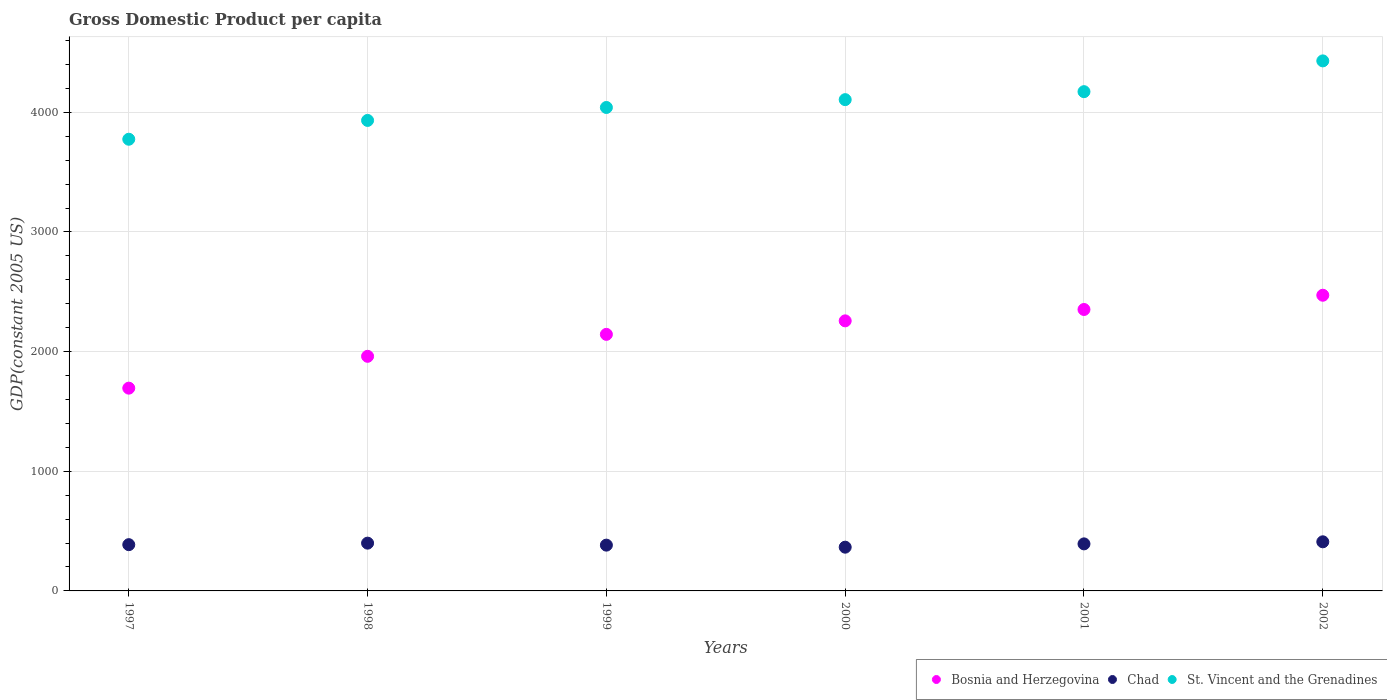How many different coloured dotlines are there?
Ensure brevity in your answer.  3. What is the GDP per capita in Bosnia and Herzegovina in 2002?
Give a very brief answer. 2471.17. Across all years, what is the maximum GDP per capita in Bosnia and Herzegovina?
Your answer should be very brief. 2471.17. Across all years, what is the minimum GDP per capita in St. Vincent and the Grenadines?
Offer a terse response. 3774.94. In which year was the GDP per capita in Bosnia and Herzegovina minimum?
Keep it short and to the point. 1997. What is the total GDP per capita in Chad in the graph?
Keep it short and to the point. 2337.76. What is the difference between the GDP per capita in St. Vincent and the Grenadines in 1999 and that in 2001?
Offer a terse response. -132.1. What is the difference between the GDP per capita in St. Vincent and the Grenadines in 1997 and the GDP per capita in Bosnia and Herzegovina in 2000?
Your answer should be compact. 1517.89. What is the average GDP per capita in Chad per year?
Offer a very short reply. 389.63. In the year 1998, what is the difference between the GDP per capita in St. Vincent and the Grenadines and GDP per capita in Chad?
Make the answer very short. 3532.86. In how many years, is the GDP per capita in Chad greater than 2800 US$?
Keep it short and to the point. 0. What is the ratio of the GDP per capita in St. Vincent and the Grenadines in 1997 to that in 1998?
Offer a terse response. 0.96. What is the difference between the highest and the second highest GDP per capita in St. Vincent and the Grenadines?
Your answer should be very brief. 257.24. What is the difference between the highest and the lowest GDP per capita in St. Vincent and the Grenadines?
Your answer should be compact. 654.8. In how many years, is the GDP per capita in St. Vincent and the Grenadines greater than the average GDP per capita in St. Vincent and the Grenadines taken over all years?
Make the answer very short. 3. Does the GDP per capita in St. Vincent and the Grenadines monotonically increase over the years?
Your answer should be very brief. Yes. How many years are there in the graph?
Give a very brief answer. 6. Are the values on the major ticks of Y-axis written in scientific E-notation?
Keep it short and to the point. No. Does the graph contain any zero values?
Ensure brevity in your answer.  No. Where does the legend appear in the graph?
Offer a terse response. Bottom right. How many legend labels are there?
Give a very brief answer. 3. How are the legend labels stacked?
Your answer should be compact. Horizontal. What is the title of the graph?
Make the answer very short. Gross Domestic Product per capita. What is the label or title of the Y-axis?
Your answer should be compact. GDP(constant 2005 US). What is the GDP(constant 2005 US) in Bosnia and Herzegovina in 1997?
Provide a succinct answer. 1694.62. What is the GDP(constant 2005 US) in Chad in 1997?
Provide a short and direct response. 386.6. What is the GDP(constant 2005 US) in St. Vincent and the Grenadines in 1997?
Your response must be concise. 3774.94. What is the GDP(constant 2005 US) in Bosnia and Herzegovina in 1998?
Offer a terse response. 1960.77. What is the GDP(constant 2005 US) of Chad in 1998?
Offer a very short reply. 399.3. What is the GDP(constant 2005 US) of St. Vincent and the Grenadines in 1998?
Offer a very short reply. 3932.16. What is the GDP(constant 2005 US) in Bosnia and Herzegovina in 1999?
Offer a very short reply. 2144.18. What is the GDP(constant 2005 US) of Chad in 1999?
Give a very brief answer. 382.64. What is the GDP(constant 2005 US) in St. Vincent and the Grenadines in 1999?
Provide a short and direct response. 4040.4. What is the GDP(constant 2005 US) in Bosnia and Herzegovina in 2000?
Give a very brief answer. 2257.05. What is the GDP(constant 2005 US) in Chad in 2000?
Your answer should be very brief. 365.61. What is the GDP(constant 2005 US) in St. Vincent and the Grenadines in 2000?
Ensure brevity in your answer.  4105.87. What is the GDP(constant 2005 US) in Bosnia and Herzegovina in 2001?
Your answer should be compact. 2352.1. What is the GDP(constant 2005 US) in Chad in 2001?
Your answer should be very brief. 393.14. What is the GDP(constant 2005 US) of St. Vincent and the Grenadines in 2001?
Your response must be concise. 4172.5. What is the GDP(constant 2005 US) of Bosnia and Herzegovina in 2002?
Keep it short and to the point. 2471.17. What is the GDP(constant 2005 US) of Chad in 2002?
Your response must be concise. 410.48. What is the GDP(constant 2005 US) of St. Vincent and the Grenadines in 2002?
Your response must be concise. 4429.74. Across all years, what is the maximum GDP(constant 2005 US) of Bosnia and Herzegovina?
Your answer should be very brief. 2471.17. Across all years, what is the maximum GDP(constant 2005 US) in Chad?
Your response must be concise. 410.48. Across all years, what is the maximum GDP(constant 2005 US) of St. Vincent and the Grenadines?
Your answer should be compact. 4429.74. Across all years, what is the minimum GDP(constant 2005 US) of Bosnia and Herzegovina?
Offer a very short reply. 1694.62. Across all years, what is the minimum GDP(constant 2005 US) of Chad?
Your answer should be compact. 365.61. Across all years, what is the minimum GDP(constant 2005 US) of St. Vincent and the Grenadines?
Keep it short and to the point. 3774.94. What is the total GDP(constant 2005 US) of Bosnia and Herzegovina in the graph?
Provide a succinct answer. 1.29e+04. What is the total GDP(constant 2005 US) of Chad in the graph?
Offer a very short reply. 2337.76. What is the total GDP(constant 2005 US) of St. Vincent and the Grenadines in the graph?
Give a very brief answer. 2.45e+04. What is the difference between the GDP(constant 2005 US) in Bosnia and Herzegovina in 1997 and that in 1998?
Make the answer very short. -266.15. What is the difference between the GDP(constant 2005 US) of Chad in 1997 and that in 1998?
Your answer should be very brief. -12.7. What is the difference between the GDP(constant 2005 US) in St. Vincent and the Grenadines in 1997 and that in 1998?
Make the answer very short. -157.22. What is the difference between the GDP(constant 2005 US) in Bosnia and Herzegovina in 1997 and that in 1999?
Keep it short and to the point. -449.57. What is the difference between the GDP(constant 2005 US) of Chad in 1997 and that in 1999?
Offer a very short reply. 3.96. What is the difference between the GDP(constant 2005 US) of St. Vincent and the Grenadines in 1997 and that in 1999?
Your answer should be very brief. -265.46. What is the difference between the GDP(constant 2005 US) of Bosnia and Herzegovina in 1997 and that in 2000?
Your answer should be very brief. -562.43. What is the difference between the GDP(constant 2005 US) of Chad in 1997 and that in 2000?
Give a very brief answer. 20.99. What is the difference between the GDP(constant 2005 US) in St. Vincent and the Grenadines in 1997 and that in 2000?
Ensure brevity in your answer.  -330.93. What is the difference between the GDP(constant 2005 US) of Bosnia and Herzegovina in 1997 and that in 2001?
Your answer should be compact. -657.48. What is the difference between the GDP(constant 2005 US) of Chad in 1997 and that in 2001?
Provide a short and direct response. -6.54. What is the difference between the GDP(constant 2005 US) in St. Vincent and the Grenadines in 1997 and that in 2001?
Make the answer very short. -397.56. What is the difference between the GDP(constant 2005 US) of Bosnia and Herzegovina in 1997 and that in 2002?
Keep it short and to the point. -776.55. What is the difference between the GDP(constant 2005 US) of Chad in 1997 and that in 2002?
Your answer should be compact. -23.89. What is the difference between the GDP(constant 2005 US) in St. Vincent and the Grenadines in 1997 and that in 2002?
Keep it short and to the point. -654.8. What is the difference between the GDP(constant 2005 US) in Bosnia and Herzegovina in 1998 and that in 1999?
Keep it short and to the point. -183.41. What is the difference between the GDP(constant 2005 US) in Chad in 1998 and that in 1999?
Provide a short and direct response. 16.66. What is the difference between the GDP(constant 2005 US) in St. Vincent and the Grenadines in 1998 and that in 1999?
Provide a succinct answer. -108.24. What is the difference between the GDP(constant 2005 US) in Bosnia and Herzegovina in 1998 and that in 2000?
Provide a succinct answer. -296.28. What is the difference between the GDP(constant 2005 US) of Chad in 1998 and that in 2000?
Your answer should be very brief. 33.69. What is the difference between the GDP(constant 2005 US) of St. Vincent and the Grenadines in 1998 and that in 2000?
Provide a short and direct response. -173.72. What is the difference between the GDP(constant 2005 US) in Bosnia and Herzegovina in 1998 and that in 2001?
Give a very brief answer. -391.33. What is the difference between the GDP(constant 2005 US) of Chad in 1998 and that in 2001?
Your answer should be very brief. 6.16. What is the difference between the GDP(constant 2005 US) of St. Vincent and the Grenadines in 1998 and that in 2001?
Give a very brief answer. -240.35. What is the difference between the GDP(constant 2005 US) of Bosnia and Herzegovina in 1998 and that in 2002?
Offer a terse response. -510.4. What is the difference between the GDP(constant 2005 US) in Chad in 1998 and that in 2002?
Your answer should be compact. -11.19. What is the difference between the GDP(constant 2005 US) of St. Vincent and the Grenadines in 1998 and that in 2002?
Make the answer very short. -497.58. What is the difference between the GDP(constant 2005 US) of Bosnia and Herzegovina in 1999 and that in 2000?
Your response must be concise. -112.87. What is the difference between the GDP(constant 2005 US) in Chad in 1999 and that in 2000?
Give a very brief answer. 17.03. What is the difference between the GDP(constant 2005 US) in St. Vincent and the Grenadines in 1999 and that in 2000?
Ensure brevity in your answer.  -65.47. What is the difference between the GDP(constant 2005 US) of Bosnia and Herzegovina in 1999 and that in 2001?
Offer a terse response. -207.92. What is the difference between the GDP(constant 2005 US) of Chad in 1999 and that in 2001?
Your response must be concise. -10.5. What is the difference between the GDP(constant 2005 US) of St. Vincent and the Grenadines in 1999 and that in 2001?
Keep it short and to the point. -132.1. What is the difference between the GDP(constant 2005 US) in Bosnia and Herzegovina in 1999 and that in 2002?
Provide a short and direct response. -326.99. What is the difference between the GDP(constant 2005 US) of Chad in 1999 and that in 2002?
Ensure brevity in your answer.  -27.84. What is the difference between the GDP(constant 2005 US) of St. Vincent and the Grenadines in 1999 and that in 2002?
Ensure brevity in your answer.  -389.34. What is the difference between the GDP(constant 2005 US) in Bosnia and Herzegovina in 2000 and that in 2001?
Offer a terse response. -95.05. What is the difference between the GDP(constant 2005 US) of Chad in 2000 and that in 2001?
Provide a short and direct response. -27.53. What is the difference between the GDP(constant 2005 US) of St. Vincent and the Grenadines in 2000 and that in 2001?
Your response must be concise. -66.63. What is the difference between the GDP(constant 2005 US) in Bosnia and Herzegovina in 2000 and that in 2002?
Give a very brief answer. -214.12. What is the difference between the GDP(constant 2005 US) in Chad in 2000 and that in 2002?
Your answer should be compact. -44.88. What is the difference between the GDP(constant 2005 US) in St. Vincent and the Grenadines in 2000 and that in 2002?
Offer a terse response. -323.87. What is the difference between the GDP(constant 2005 US) in Bosnia and Herzegovina in 2001 and that in 2002?
Your response must be concise. -119.07. What is the difference between the GDP(constant 2005 US) in Chad in 2001 and that in 2002?
Keep it short and to the point. -17.34. What is the difference between the GDP(constant 2005 US) in St. Vincent and the Grenadines in 2001 and that in 2002?
Ensure brevity in your answer.  -257.24. What is the difference between the GDP(constant 2005 US) in Bosnia and Herzegovina in 1997 and the GDP(constant 2005 US) in Chad in 1998?
Your answer should be compact. 1295.32. What is the difference between the GDP(constant 2005 US) in Bosnia and Herzegovina in 1997 and the GDP(constant 2005 US) in St. Vincent and the Grenadines in 1998?
Your answer should be very brief. -2237.54. What is the difference between the GDP(constant 2005 US) of Chad in 1997 and the GDP(constant 2005 US) of St. Vincent and the Grenadines in 1998?
Provide a succinct answer. -3545.56. What is the difference between the GDP(constant 2005 US) in Bosnia and Herzegovina in 1997 and the GDP(constant 2005 US) in Chad in 1999?
Your answer should be very brief. 1311.98. What is the difference between the GDP(constant 2005 US) of Bosnia and Herzegovina in 1997 and the GDP(constant 2005 US) of St. Vincent and the Grenadines in 1999?
Provide a short and direct response. -2345.78. What is the difference between the GDP(constant 2005 US) of Chad in 1997 and the GDP(constant 2005 US) of St. Vincent and the Grenadines in 1999?
Your response must be concise. -3653.8. What is the difference between the GDP(constant 2005 US) of Bosnia and Herzegovina in 1997 and the GDP(constant 2005 US) of Chad in 2000?
Make the answer very short. 1329.01. What is the difference between the GDP(constant 2005 US) in Bosnia and Herzegovina in 1997 and the GDP(constant 2005 US) in St. Vincent and the Grenadines in 2000?
Offer a terse response. -2411.26. What is the difference between the GDP(constant 2005 US) in Chad in 1997 and the GDP(constant 2005 US) in St. Vincent and the Grenadines in 2000?
Your answer should be very brief. -3719.28. What is the difference between the GDP(constant 2005 US) of Bosnia and Herzegovina in 1997 and the GDP(constant 2005 US) of Chad in 2001?
Provide a short and direct response. 1301.48. What is the difference between the GDP(constant 2005 US) in Bosnia and Herzegovina in 1997 and the GDP(constant 2005 US) in St. Vincent and the Grenadines in 2001?
Offer a very short reply. -2477.88. What is the difference between the GDP(constant 2005 US) of Chad in 1997 and the GDP(constant 2005 US) of St. Vincent and the Grenadines in 2001?
Your response must be concise. -3785.91. What is the difference between the GDP(constant 2005 US) of Bosnia and Herzegovina in 1997 and the GDP(constant 2005 US) of Chad in 2002?
Offer a very short reply. 1284.14. What is the difference between the GDP(constant 2005 US) of Bosnia and Herzegovina in 1997 and the GDP(constant 2005 US) of St. Vincent and the Grenadines in 2002?
Your answer should be very brief. -2735.12. What is the difference between the GDP(constant 2005 US) in Chad in 1997 and the GDP(constant 2005 US) in St. Vincent and the Grenadines in 2002?
Your answer should be very brief. -4043.14. What is the difference between the GDP(constant 2005 US) of Bosnia and Herzegovina in 1998 and the GDP(constant 2005 US) of Chad in 1999?
Your response must be concise. 1578.13. What is the difference between the GDP(constant 2005 US) in Bosnia and Herzegovina in 1998 and the GDP(constant 2005 US) in St. Vincent and the Grenadines in 1999?
Make the answer very short. -2079.63. What is the difference between the GDP(constant 2005 US) of Chad in 1998 and the GDP(constant 2005 US) of St. Vincent and the Grenadines in 1999?
Offer a very short reply. -3641.1. What is the difference between the GDP(constant 2005 US) of Bosnia and Herzegovina in 1998 and the GDP(constant 2005 US) of Chad in 2000?
Your answer should be very brief. 1595.16. What is the difference between the GDP(constant 2005 US) of Bosnia and Herzegovina in 1998 and the GDP(constant 2005 US) of St. Vincent and the Grenadines in 2000?
Your answer should be compact. -2145.1. What is the difference between the GDP(constant 2005 US) of Chad in 1998 and the GDP(constant 2005 US) of St. Vincent and the Grenadines in 2000?
Your response must be concise. -3706.58. What is the difference between the GDP(constant 2005 US) of Bosnia and Herzegovina in 1998 and the GDP(constant 2005 US) of Chad in 2001?
Give a very brief answer. 1567.63. What is the difference between the GDP(constant 2005 US) in Bosnia and Herzegovina in 1998 and the GDP(constant 2005 US) in St. Vincent and the Grenadines in 2001?
Give a very brief answer. -2211.73. What is the difference between the GDP(constant 2005 US) in Chad in 1998 and the GDP(constant 2005 US) in St. Vincent and the Grenadines in 2001?
Ensure brevity in your answer.  -3773.21. What is the difference between the GDP(constant 2005 US) of Bosnia and Herzegovina in 1998 and the GDP(constant 2005 US) of Chad in 2002?
Ensure brevity in your answer.  1550.29. What is the difference between the GDP(constant 2005 US) in Bosnia and Herzegovina in 1998 and the GDP(constant 2005 US) in St. Vincent and the Grenadines in 2002?
Your answer should be very brief. -2468.97. What is the difference between the GDP(constant 2005 US) of Chad in 1998 and the GDP(constant 2005 US) of St. Vincent and the Grenadines in 2002?
Offer a very short reply. -4030.44. What is the difference between the GDP(constant 2005 US) in Bosnia and Herzegovina in 1999 and the GDP(constant 2005 US) in Chad in 2000?
Your answer should be very brief. 1778.58. What is the difference between the GDP(constant 2005 US) of Bosnia and Herzegovina in 1999 and the GDP(constant 2005 US) of St. Vincent and the Grenadines in 2000?
Provide a succinct answer. -1961.69. What is the difference between the GDP(constant 2005 US) in Chad in 1999 and the GDP(constant 2005 US) in St. Vincent and the Grenadines in 2000?
Offer a very short reply. -3723.24. What is the difference between the GDP(constant 2005 US) of Bosnia and Herzegovina in 1999 and the GDP(constant 2005 US) of Chad in 2001?
Provide a short and direct response. 1751.05. What is the difference between the GDP(constant 2005 US) in Bosnia and Herzegovina in 1999 and the GDP(constant 2005 US) in St. Vincent and the Grenadines in 2001?
Offer a terse response. -2028.32. What is the difference between the GDP(constant 2005 US) of Chad in 1999 and the GDP(constant 2005 US) of St. Vincent and the Grenadines in 2001?
Provide a succinct answer. -3789.86. What is the difference between the GDP(constant 2005 US) in Bosnia and Herzegovina in 1999 and the GDP(constant 2005 US) in Chad in 2002?
Keep it short and to the point. 1733.7. What is the difference between the GDP(constant 2005 US) in Bosnia and Herzegovina in 1999 and the GDP(constant 2005 US) in St. Vincent and the Grenadines in 2002?
Your response must be concise. -2285.56. What is the difference between the GDP(constant 2005 US) of Chad in 1999 and the GDP(constant 2005 US) of St. Vincent and the Grenadines in 2002?
Make the answer very short. -4047.1. What is the difference between the GDP(constant 2005 US) of Bosnia and Herzegovina in 2000 and the GDP(constant 2005 US) of Chad in 2001?
Offer a very short reply. 1863.91. What is the difference between the GDP(constant 2005 US) in Bosnia and Herzegovina in 2000 and the GDP(constant 2005 US) in St. Vincent and the Grenadines in 2001?
Your response must be concise. -1915.45. What is the difference between the GDP(constant 2005 US) of Chad in 2000 and the GDP(constant 2005 US) of St. Vincent and the Grenadines in 2001?
Give a very brief answer. -3806.9. What is the difference between the GDP(constant 2005 US) in Bosnia and Herzegovina in 2000 and the GDP(constant 2005 US) in Chad in 2002?
Ensure brevity in your answer.  1846.57. What is the difference between the GDP(constant 2005 US) in Bosnia and Herzegovina in 2000 and the GDP(constant 2005 US) in St. Vincent and the Grenadines in 2002?
Your response must be concise. -2172.69. What is the difference between the GDP(constant 2005 US) of Chad in 2000 and the GDP(constant 2005 US) of St. Vincent and the Grenadines in 2002?
Offer a very short reply. -4064.13. What is the difference between the GDP(constant 2005 US) in Bosnia and Herzegovina in 2001 and the GDP(constant 2005 US) in Chad in 2002?
Make the answer very short. 1941.62. What is the difference between the GDP(constant 2005 US) of Bosnia and Herzegovina in 2001 and the GDP(constant 2005 US) of St. Vincent and the Grenadines in 2002?
Provide a short and direct response. -2077.64. What is the difference between the GDP(constant 2005 US) in Chad in 2001 and the GDP(constant 2005 US) in St. Vincent and the Grenadines in 2002?
Offer a very short reply. -4036.6. What is the average GDP(constant 2005 US) in Bosnia and Herzegovina per year?
Make the answer very short. 2146.65. What is the average GDP(constant 2005 US) of Chad per year?
Offer a very short reply. 389.63. What is the average GDP(constant 2005 US) in St. Vincent and the Grenadines per year?
Offer a terse response. 4075.93. In the year 1997, what is the difference between the GDP(constant 2005 US) of Bosnia and Herzegovina and GDP(constant 2005 US) of Chad?
Ensure brevity in your answer.  1308.02. In the year 1997, what is the difference between the GDP(constant 2005 US) of Bosnia and Herzegovina and GDP(constant 2005 US) of St. Vincent and the Grenadines?
Your response must be concise. -2080.32. In the year 1997, what is the difference between the GDP(constant 2005 US) in Chad and GDP(constant 2005 US) in St. Vincent and the Grenadines?
Your answer should be compact. -3388.34. In the year 1998, what is the difference between the GDP(constant 2005 US) of Bosnia and Herzegovina and GDP(constant 2005 US) of Chad?
Give a very brief answer. 1561.47. In the year 1998, what is the difference between the GDP(constant 2005 US) of Bosnia and Herzegovina and GDP(constant 2005 US) of St. Vincent and the Grenadines?
Your response must be concise. -1971.38. In the year 1998, what is the difference between the GDP(constant 2005 US) of Chad and GDP(constant 2005 US) of St. Vincent and the Grenadines?
Ensure brevity in your answer.  -3532.86. In the year 1999, what is the difference between the GDP(constant 2005 US) of Bosnia and Herzegovina and GDP(constant 2005 US) of Chad?
Offer a very short reply. 1761.55. In the year 1999, what is the difference between the GDP(constant 2005 US) in Bosnia and Herzegovina and GDP(constant 2005 US) in St. Vincent and the Grenadines?
Make the answer very short. -1896.22. In the year 1999, what is the difference between the GDP(constant 2005 US) of Chad and GDP(constant 2005 US) of St. Vincent and the Grenadines?
Your answer should be very brief. -3657.76. In the year 2000, what is the difference between the GDP(constant 2005 US) of Bosnia and Herzegovina and GDP(constant 2005 US) of Chad?
Give a very brief answer. 1891.44. In the year 2000, what is the difference between the GDP(constant 2005 US) in Bosnia and Herzegovina and GDP(constant 2005 US) in St. Vincent and the Grenadines?
Provide a succinct answer. -1848.82. In the year 2000, what is the difference between the GDP(constant 2005 US) in Chad and GDP(constant 2005 US) in St. Vincent and the Grenadines?
Your answer should be very brief. -3740.27. In the year 2001, what is the difference between the GDP(constant 2005 US) of Bosnia and Herzegovina and GDP(constant 2005 US) of Chad?
Keep it short and to the point. 1958.96. In the year 2001, what is the difference between the GDP(constant 2005 US) of Bosnia and Herzegovina and GDP(constant 2005 US) of St. Vincent and the Grenadines?
Offer a terse response. -1820.4. In the year 2001, what is the difference between the GDP(constant 2005 US) in Chad and GDP(constant 2005 US) in St. Vincent and the Grenadines?
Offer a very short reply. -3779.36. In the year 2002, what is the difference between the GDP(constant 2005 US) of Bosnia and Herzegovina and GDP(constant 2005 US) of Chad?
Keep it short and to the point. 2060.69. In the year 2002, what is the difference between the GDP(constant 2005 US) of Bosnia and Herzegovina and GDP(constant 2005 US) of St. Vincent and the Grenadines?
Your response must be concise. -1958.57. In the year 2002, what is the difference between the GDP(constant 2005 US) of Chad and GDP(constant 2005 US) of St. Vincent and the Grenadines?
Give a very brief answer. -4019.26. What is the ratio of the GDP(constant 2005 US) of Bosnia and Herzegovina in 1997 to that in 1998?
Your answer should be very brief. 0.86. What is the ratio of the GDP(constant 2005 US) of Chad in 1997 to that in 1998?
Keep it short and to the point. 0.97. What is the ratio of the GDP(constant 2005 US) in St. Vincent and the Grenadines in 1997 to that in 1998?
Your answer should be very brief. 0.96. What is the ratio of the GDP(constant 2005 US) of Bosnia and Herzegovina in 1997 to that in 1999?
Ensure brevity in your answer.  0.79. What is the ratio of the GDP(constant 2005 US) in Chad in 1997 to that in 1999?
Provide a short and direct response. 1.01. What is the ratio of the GDP(constant 2005 US) in St. Vincent and the Grenadines in 1997 to that in 1999?
Your response must be concise. 0.93. What is the ratio of the GDP(constant 2005 US) of Bosnia and Herzegovina in 1997 to that in 2000?
Your response must be concise. 0.75. What is the ratio of the GDP(constant 2005 US) in Chad in 1997 to that in 2000?
Your answer should be compact. 1.06. What is the ratio of the GDP(constant 2005 US) of St. Vincent and the Grenadines in 1997 to that in 2000?
Keep it short and to the point. 0.92. What is the ratio of the GDP(constant 2005 US) in Bosnia and Herzegovina in 1997 to that in 2001?
Give a very brief answer. 0.72. What is the ratio of the GDP(constant 2005 US) of Chad in 1997 to that in 2001?
Make the answer very short. 0.98. What is the ratio of the GDP(constant 2005 US) of St. Vincent and the Grenadines in 1997 to that in 2001?
Provide a short and direct response. 0.9. What is the ratio of the GDP(constant 2005 US) in Bosnia and Herzegovina in 1997 to that in 2002?
Provide a succinct answer. 0.69. What is the ratio of the GDP(constant 2005 US) in Chad in 1997 to that in 2002?
Provide a succinct answer. 0.94. What is the ratio of the GDP(constant 2005 US) in St. Vincent and the Grenadines in 1997 to that in 2002?
Your answer should be compact. 0.85. What is the ratio of the GDP(constant 2005 US) in Bosnia and Herzegovina in 1998 to that in 1999?
Give a very brief answer. 0.91. What is the ratio of the GDP(constant 2005 US) of Chad in 1998 to that in 1999?
Ensure brevity in your answer.  1.04. What is the ratio of the GDP(constant 2005 US) of St. Vincent and the Grenadines in 1998 to that in 1999?
Offer a very short reply. 0.97. What is the ratio of the GDP(constant 2005 US) in Bosnia and Herzegovina in 1998 to that in 2000?
Provide a short and direct response. 0.87. What is the ratio of the GDP(constant 2005 US) in Chad in 1998 to that in 2000?
Your response must be concise. 1.09. What is the ratio of the GDP(constant 2005 US) of St. Vincent and the Grenadines in 1998 to that in 2000?
Your answer should be very brief. 0.96. What is the ratio of the GDP(constant 2005 US) in Bosnia and Herzegovina in 1998 to that in 2001?
Your answer should be compact. 0.83. What is the ratio of the GDP(constant 2005 US) of Chad in 1998 to that in 2001?
Provide a succinct answer. 1.02. What is the ratio of the GDP(constant 2005 US) in St. Vincent and the Grenadines in 1998 to that in 2001?
Give a very brief answer. 0.94. What is the ratio of the GDP(constant 2005 US) in Bosnia and Herzegovina in 1998 to that in 2002?
Your answer should be very brief. 0.79. What is the ratio of the GDP(constant 2005 US) in Chad in 1998 to that in 2002?
Your answer should be compact. 0.97. What is the ratio of the GDP(constant 2005 US) of St. Vincent and the Grenadines in 1998 to that in 2002?
Your answer should be very brief. 0.89. What is the ratio of the GDP(constant 2005 US) of Chad in 1999 to that in 2000?
Your answer should be compact. 1.05. What is the ratio of the GDP(constant 2005 US) in St. Vincent and the Grenadines in 1999 to that in 2000?
Your answer should be compact. 0.98. What is the ratio of the GDP(constant 2005 US) in Bosnia and Herzegovina in 1999 to that in 2001?
Make the answer very short. 0.91. What is the ratio of the GDP(constant 2005 US) in Chad in 1999 to that in 2001?
Your answer should be very brief. 0.97. What is the ratio of the GDP(constant 2005 US) of St. Vincent and the Grenadines in 1999 to that in 2001?
Offer a terse response. 0.97. What is the ratio of the GDP(constant 2005 US) of Bosnia and Herzegovina in 1999 to that in 2002?
Provide a succinct answer. 0.87. What is the ratio of the GDP(constant 2005 US) in Chad in 1999 to that in 2002?
Give a very brief answer. 0.93. What is the ratio of the GDP(constant 2005 US) in St. Vincent and the Grenadines in 1999 to that in 2002?
Provide a short and direct response. 0.91. What is the ratio of the GDP(constant 2005 US) of Bosnia and Herzegovina in 2000 to that in 2001?
Offer a very short reply. 0.96. What is the ratio of the GDP(constant 2005 US) in Bosnia and Herzegovina in 2000 to that in 2002?
Keep it short and to the point. 0.91. What is the ratio of the GDP(constant 2005 US) of Chad in 2000 to that in 2002?
Provide a short and direct response. 0.89. What is the ratio of the GDP(constant 2005 US) of St. Vincent and the Grenadines in 2000 to that in 2002?
Provide a short and direct response. 0.93. What is the ratio of the GDP(constant 2005 US) in Bosnia and Herzegovina in 2001 to that in 2002?
Offer a terse response. 0.95. What is the ratio of the GDP(constant 2005 US) of Chad in 2001 to that in 2002?
Ensure brevity in your answer.  0.96. What is the ratio of the GDP(constant 2005 US) of St. Vincent and the Grenadines in 2001 to that in 2002?
Your response must be concise. 0.94. What is the difference between the highest and the second highest GDP(constant 2005 US) in Bosnia and Herzegovina?
Provide a short and direct response. 119.07. What is the difference between the highest and the second highest GDP(constant 2005 US) in Chad?
Ensure brevity in your answer.  11.19. What is the difference between the highest and the second highest GDP(constant 2005 US) of St. Vincent and the Grenadines?
Offer a very short reply. 257.24. What is the difference between the highest and the lowest GDP(constant 2005 US) of Bosnia and Herzegovina?
Your answer should be very brief. 776.55. What is the difference between the highest and the lowest GDP(constant 2005 US) in Chad?
Provide a short and direct response. 44.88. What is the difference between the highest and the lowest GDP(constant 2005 US) of St. Vincent and the Grenadines?
Make the answer very short. 654.8. 